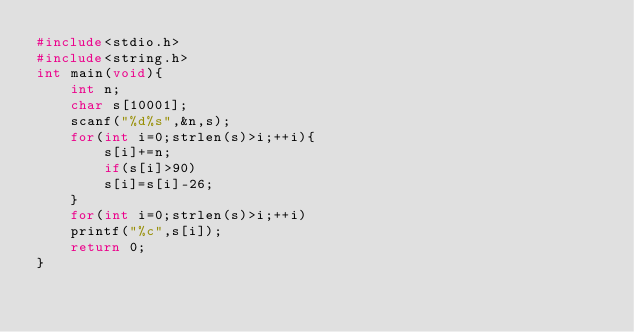Convert code to text. <code><loc_0><loc_0><loc_500><loc_500><_C_>#include<stdio.h>
#include<string.h>
int main(void){
    int n;
    char s[10001];
    scanf("%d%s",&n,s);
    for(int i=0;strlen(s)>i;++i){
        s[i]+=n;
        if(s[i]>90)
        s[i]=s[i]-26;
    }
    for(int i=0;strlen(s)>i;++i)
    printf("%c",s[i]);
    return 0;
}</code> 